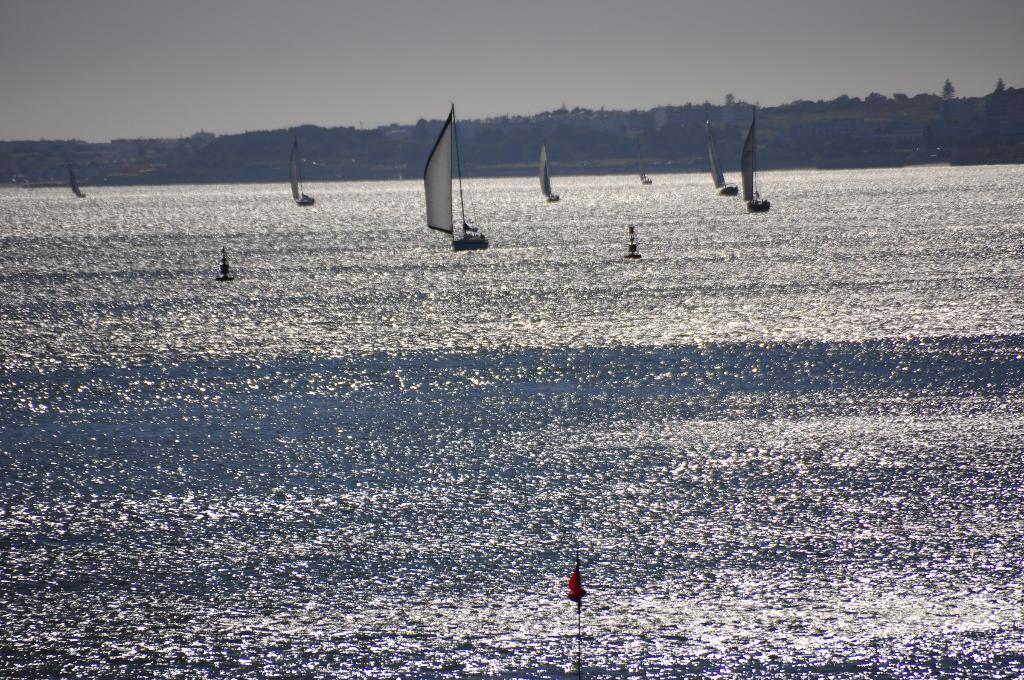In one or two sentences, can you explain what this image depicts? In this image, we can see boats with flags are on the water. In the background, there are hills and trees. At the top, there is sky. 